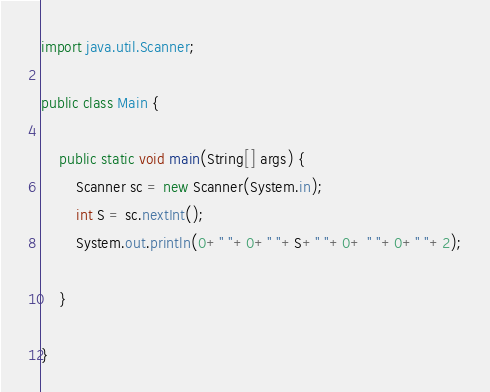Convert code to text. <code><loc_0><loc_0><loc_500><loc_500><_Java_>import java.util.Scanner;

public class Main {

	public static void main(String[] args) {
		Scanner sc = new Scanner(System.in);
		int S = sc.nextInt();
		System.out.println(0+" "+0+" "+S+" "+0+ " "+0+" "+2);

	}

}</code> 